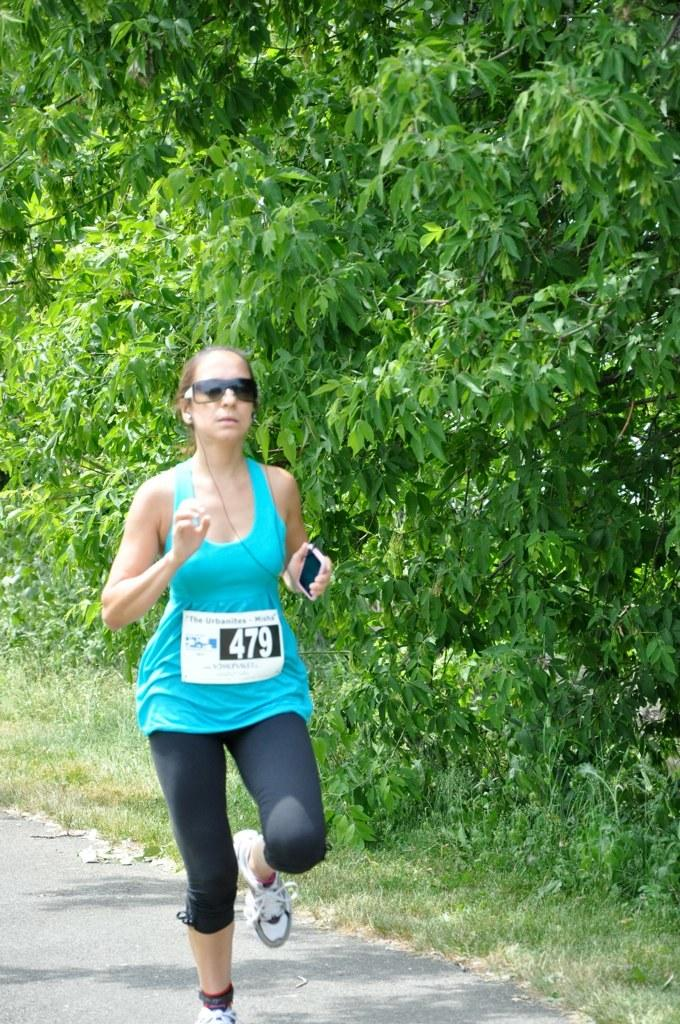What is the main subject of the image? The main subject of the image is a woman. What is the woman doing in the image? The woman is running in the image. What is the woman wearing on her upper body? The woman is wearing a blue top. What is the woman wearing on her lower body? The woman is wearing black trousers. What protective gear is the woman wearing? The woman is wearing goggles. What can be seen on the right side of the image? There are trees on the right side of the image. What type of amusement can be seen in the image? There is no amusement present in the image; it features a woman running while wearing goggles. What is the woman preparing for dinner in the image? There is no indication that the woman is preparing for dinner in the image. 